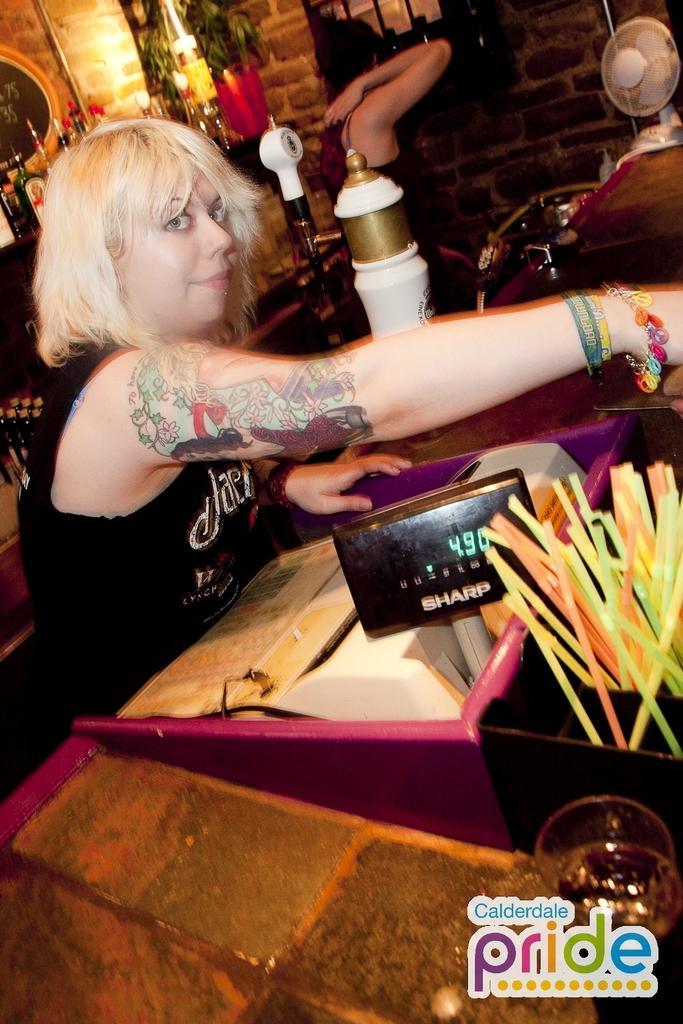Describe this image in one or two sentences. On the left side there is a woman wearing black color dress, facing towards the right side and looking at the picture. In front of her there is a table on which many objects are placed. In the background there is one more person and also I can see a wall, bottles, a frame is attached to the wall and a plant. 